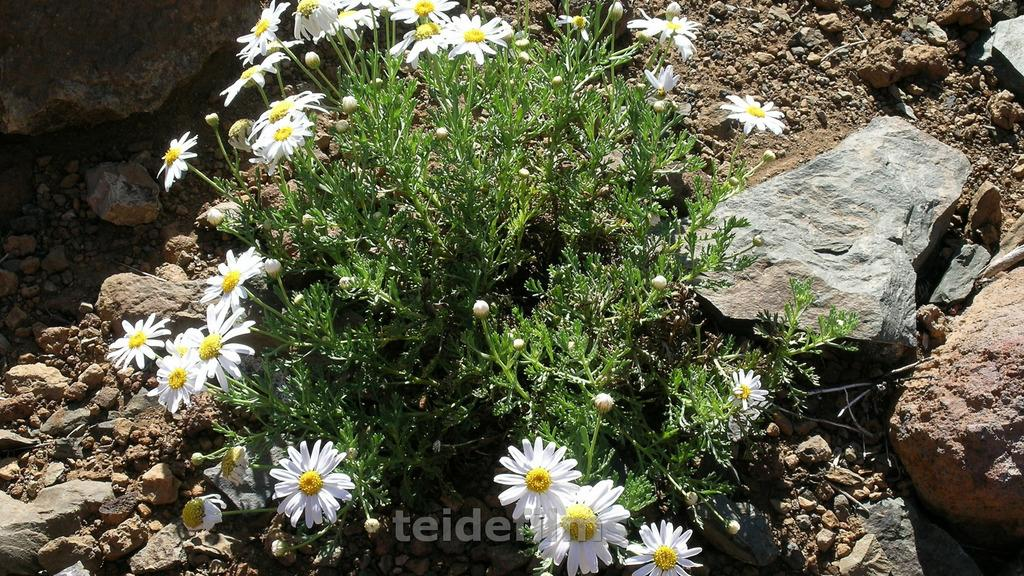What type of living organisms can be seen in the image? Plants and flowers are visible in the image. What other objects can be seen in the image? There are rocks and stones in the image. What scent can be detected from the flowers in the image? The image does not provide information about the scent of the flowers, so it cannot be determined from the image. 